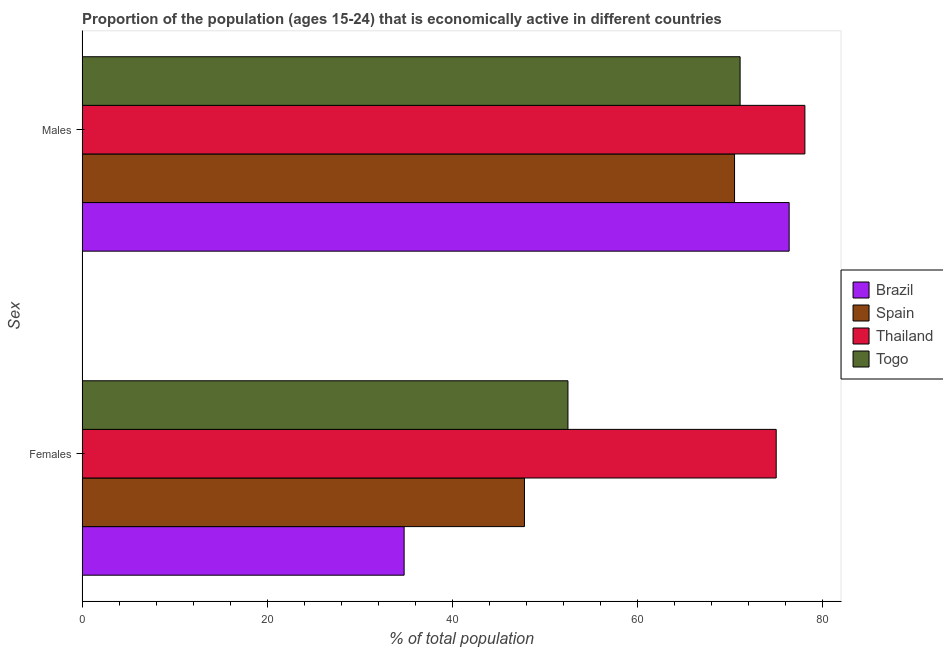How many groups of bars are there?
Your response must be concise. 2. Are the number of bars per tick equal to the number of legend labels?
Give a very brief answer. Yes. Are the number of bars on each tick of the Y-axis equal?
Give a very brief answer. Yes. How many bars are there on the 2nd tick from the bottom?
Provide a succinct answer. 4. What is the label of the 1st group of bars from the top?
Provide a succinct answer. Males. What is the percentage of economically active female population in Togo?
Offer a terse response. 52.5. Across all countries, what is the maximum percentage of economically active female population?
Offer a very short reply. 75. Across all countries, what is the minimum percentage of economically active male population?
Offer a terse response. 70.5. In which country was the percentage of economically active male population maximum?
Your response must be concise. Thailand. In which country was the percentage of economically active male population minimum?
Keep it short and to the point. Spain. What is the total percentage of economically active female population in the graph?
Offer a very short reply. 210.1. What is the difference between the percentage of economically active female population in Brazil and that in Togo?
Keep it short and to the point. -17.7. What is the difference between the percentage of economically active female population in Brazil and the percentage of economically active male population in Spain?
Provide a short and direct response. -35.7. What is the average percentage of economically active female population per country?
Give a very brief answer. 52.52. What is the difference between the percentage of economically active male population and percentage of economically active female population in Brazil?
Your answer should be compact. 41.6. In how many countries, is the percentage of economically active male population greater than 32 %?
Provide a short and direct response. 4. What is the ratio of the percentage of economically active female population in Togo to that in Thailand?
Offer a terse response. 0.7. What does the 3rd bar from the bottom in Males represents?
Give a very brief answer. Thailand. What is the difference between two consecutive major ticks on the X-axis?
Ensure brevity in your answer.  20. Does the graph contain grids?
Ensure brevity in your answer.  No. Where does the legend appear in the graph?
Your answer should be compact. Center right. What is the title of the graph?
Your response must be concise. Proportion of the population (ages 15-24) that is economically active in different countries. Does "Kazakhstan" appear as one of the legend labels in the graph?
Give a very brief answer. No. What is the label or title of the X-axis?
Offer a terse response. % of total population. What is the label or title of the Y-axis?
Make the answer very short. Sex. What is the % of total population of Brazil in Females?
Your answer should be very brief. 34.8. What is the % of total population of Spain in Females?
Make the answer very short. 47.8. What is the % of total population of Togo in Females?
Keep it short and to the point. 52.5. What is the % of total population of Brazil in Males?
Keep it short and to the point. 76.4. What is the % of total population in Spain in Males?
Your response must be concise. 70.5. What is the % of total population of Thailand in Males?
Make the answer very short. 78.1. What is the % of total population in Togo in Males?
Ensure brevity in your answer.  71.1. Across all Sex, what is the maximum % of total population in Brazil?
Your answer should be compact. 76.4. Across all Sex, what is the maximum % of total population in Spain?
Your answer should be very brief. 70.5. Across all Sex, what is the maximum % of total population in Thailand?
Provide a short and direct response. 78.1. Across all Sex, what is the maximum % of total population in Togo?
Your answer should be very brief. 71.1. Across all Sex, what is the minimum % of total population of Brazil?
Offer a terse response. 34.8. Across all Sex, what is the minimum % of total population of Spain?
Offer a very short reply. 47.8. Across all Sex, what is the minimum % of total population in Thailand?
Your answer should be compact. 75. Across all Sex, what is the minimum % of total population of Togo?
Provide a short and direct response. 52.5. What is the total % of total population of Brazil in the graph?
Offer a very short reply. 111.2. What is the total % of total population in Spain in the graph?
Keep it short and to the point. 118.3. What is the total % of total population of Thailand in the graph?
Provide a succinct answer. 153.1. What is the total % of total population in Togo in the graph?
Offer a very short reply. 123.6. What is the difference between the % of total population in Brazil in Females and that in Males?
Make the answer very short. -41.6. What is the difference between the % of total population of Spain in Females and that in Males?
Your answer should be compact. -22.7. What is the difference between the % of total population in Togo in Females and that in Males?
Your answer should be very brief. -18.6. What is the difference between the % of total population of Brazil in Females and the % of total population of Spain in Males?
Your answer should be compact. -35.7. What is the difference between the % of total population of Brazil in Females and the % of total population of Thailand in Males?
Provide a succinct answer. -43.3. What is the difference between the % of total population of Brazil in Females and the % of total population of Togo in Males?
Provide a succinct answer. -36.3. What is the difference between the % of total population in Spain in Females and the % of total population in Thailand in Males?
Your answer should be very brief. -30.3. What is the difference between the % of total population in Spain in Females and the % of total population in Togo in Males?
Your response must be concise. -23.3. What is the average % of total population of Brazil per Sex?
Your response must be concise. 55.6. What is the average % of total population of Spain per Sex?
Provide a short and direct response. 59.15. What is the average % of total population of Thailand per Sex?
Your answer should be compact. 76.55. What is the average % of total population of Togo per Sex?
Your answer should be very brief. 61.8. What is the difference between the % of total population of Brazil and % of total population of Spain in Females?
Offer a terse response. -13. What is the difference between the % of total population in Brazil and % of total population in Thailand in Females?
Your answer should be very brief. -40.2. What is the difference between the % of total population of Brazil and % of total population of Togo in Females?
Make the answer very short. -17.7. What is the difference between the % of total population in Spain and % of total population in Thailand in Females?
Keep it short and to the point. -27.2. What is the difference between the % of total population in Thailand and % of total population in Togo in Females?
Provide a short and direct response. 22.5. What is the difference between the % of total population of Spain and % of total population of Thailand in Males?
Ensure brevity in your answer.  -7.6. What is the difference between the % of total population of Spain and % of total population of Togo in Males?
Your answer should be very brief. -0.6. What is the difference between the % of total population of Thailand and % of total population of Togo in Males?
Offer a very short reply. 7. What is the ratio of the % of total population of Brazil in Females to that in Males?
Your answer should be very brief. 0.46. What is the ratio of the % of total population of Spain in Females to that in Males?
Provide a succinct answer. 0.68. What is the ratio of the % of total population in Thailand in Females to that in Males?
Provide a succinct answer. 0.96. What is the ratio of the % of total population in Togo in Females to that in Males?
Offer a terse response. 0.74. What is the difference between the highest and the second highest % of total population of Brazil?
Offer a terse response. 41.6. What is the difference between the highest and the second highest % of total population of Spain?
Your answer should be compact. 22.7. What is the difference between the highest and the second highest % of total population in Thailand?
Provide a short and direct response. 3.1. What is the difference between the highest and the second highest % of total population in Togo?
Give a very brief answer. 18.6. What is the difference between the highest and the lowest % of total population in Brazil?
Provide a succinct answer. 41.6. What is the difference between the highest and the lowest % of total population of Spain?
Provide a succinct answer. 22.7. What is the difference between the highest and the lowest % of total population of Togo?
Provide a succinct answer. 18.6. 